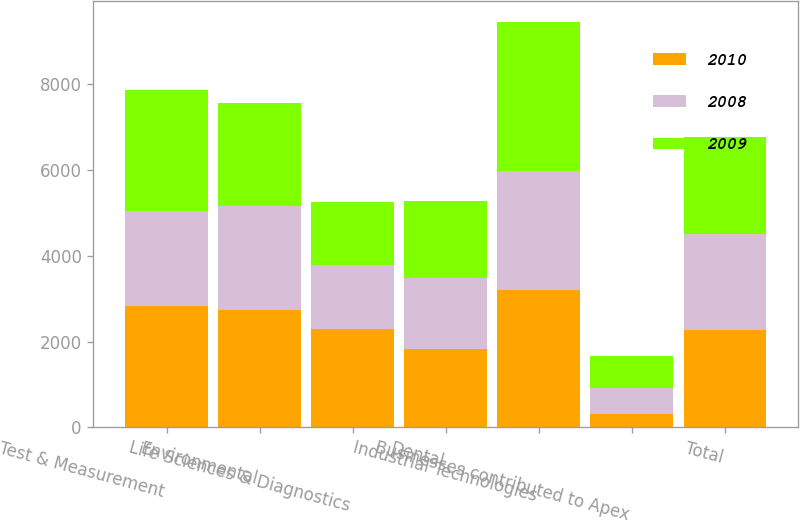Convert chart. <chart><loc_0><loc_0><loc_500><loc_500><stacked_bar_chart><ecel><fcel>Test & Measurement<fcel>Environmental<fcel>Life Sciences & Diagnostics<fcel>Dental<fcel>Industrial Technologies<fcel>Businesses contributed to Apex<fcel>Total<nl><fcel>2010<fcel>2832.9<fcel>2738<fcel>2298.3<fcel>1824.6<fcel>3193.2<fcel>315.6<fcel>2259.8<nl><fcel>2008<fcel>2221.3<fcel>2418.7<fcel>1484.9<fcel>1657<fcel>2795.1<fcel>607.9<fcel>2259.8<nl><fcel>2009<fcel>2805<fcel>2413.2<fcel>1481.5<fcel>1795.5<fcel>3471<fcel>731.3<fcel>2259.8<nl></chart> 